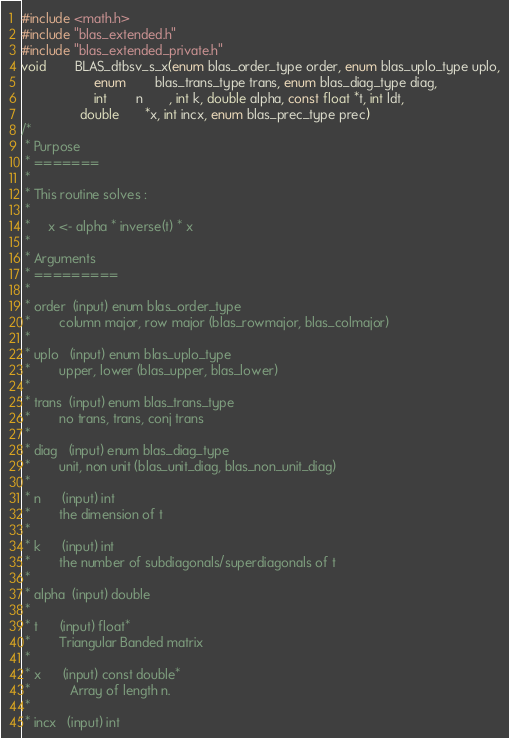<code> <loc_0><loc_0><loc_500><loc_500><_C_>#include <math.h>
#include "blas_extended.h"
#include "blas_extended_private.h"
void		BLAS_dtbsv_s_x(enum blas_order_type order, enum blas_uplo_type uplo,
		     		enum		blas_trans_type trans, enum blas_diag_type diag,
		     		int		n       , int k, double alpha, const float *t, int ldt,
	     		double       *x, int incx, enum blas_prec_type prec)
/*
 * Purpose
 * =======
 *
 * This routine solves :
 *
 *     x <- alpha * inverse(t) * x
 *
 * Arguments
 * =========
 *
 * order  (input) enum blas_order_type
 *        column major, row major (blas_rowmajor, blas_colmajor)
 *
 * uplo   (input) enum blas_uplo_type
 *        upper, lower (blas_upper, blas_lower)
 *
 * trans  (input) enum blas_trans_type
 *        no trans, trans, conj trans
 *
 * diag   (input) enum blas_diag_type
 *        unit, non unit (blas_unit_diag, blas_non_unit_diag)
 *
 * n      (input) int
 *        the dimension of t
 *
 * k      (input) int
 *        the number of subdiagonals/superdiagonals of t
 *
 * alpha  (input) double
 *
 * t      (input) float*
 *        Triangular Banded matrix
 *
 * x      (input) const double*
 *           Array of length n.
 *
 * incx   (input) int</code> 